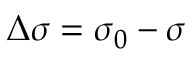Convert formula to latex. <formula><loc_0><loc_0><loc_500><loc_500>\Delta \sigma = \sigma _ { 0 } - \sigma</formula> 